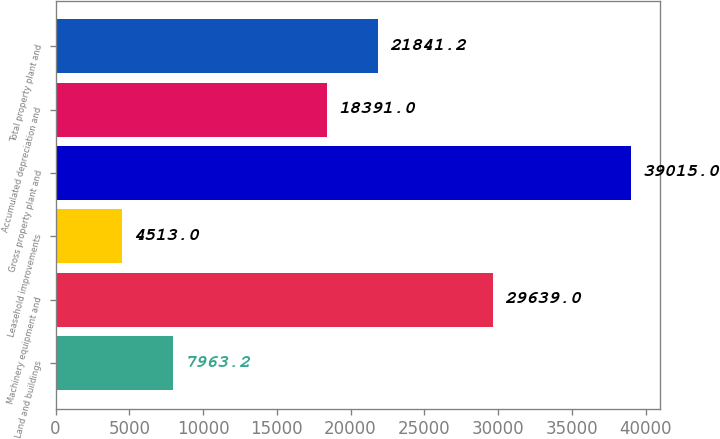Convert chart to OTSL. <chart><loc_0><loc_0><loc_500><loc_500><bar_chart><fcel>Land and buildings<fcel>Machinery equipment and<fcel>Leasehold improvements<fcel>Gross property plant and<fcel>Accumulated depreciation and<fcel>Total property plant and<nl><fcel>7963.2<fcel>29639<fcel>4513<fcel>39015<fcel>18391<fcel>21841.2<nl></chart> 